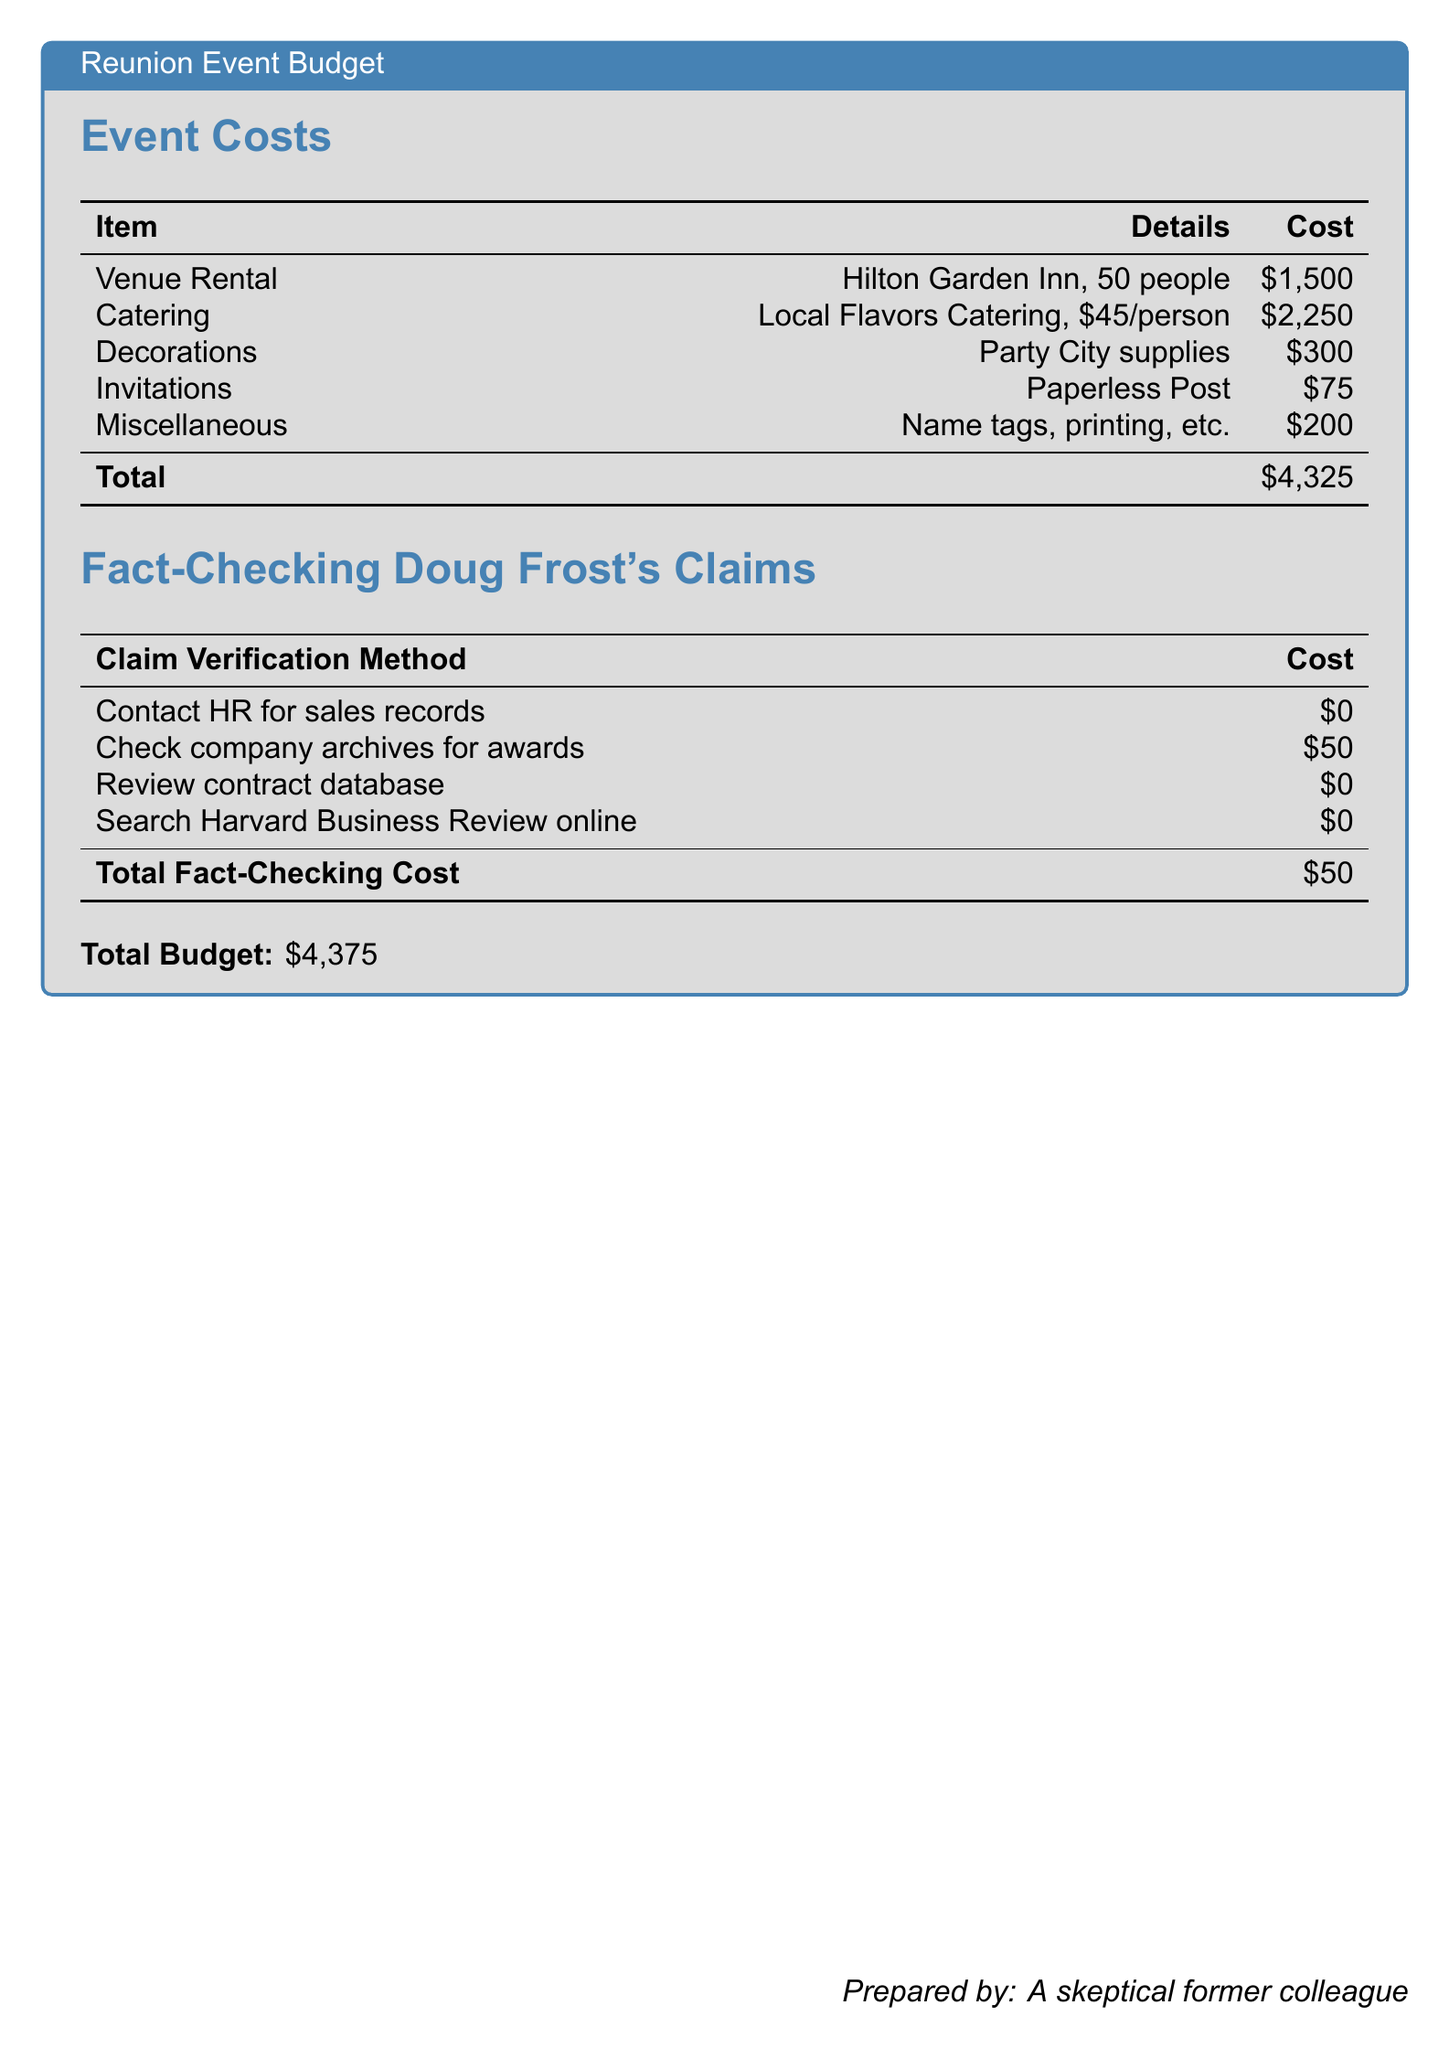What is the total cost of the reunion event? The total cost is listed in the budget section, which sums up all individual costs, amounting to $4,325.
Answer: $4,325 How much is allocated for catering per person? The catering cost is specified as $45 per person in the details.
Answer: $45 What is the total fact-checking cost? The total fact-checking cost is provided in the section detailing verification methods, which is $50.
Answer: $50 How many people is the venue rental for? The venue rental information indicates it is for 50 people.
Answer: 50 people What is the cost of decorations? The decorations cost is detailed in the budget as $300.
Answer: $300 What is the total budget for the reunion event including fact-checking? The total budget adds both the reunion event and fact-checking costs together, which is $4,325 + $50 = $4,375.
Answer: $4,375 How much does checking company archives for awards cost? The document states that checking company archives for awards incurs a cost of $50.
Answer: $50 What type of document is this? The document format is identified as an event budget for a reunion.
Answer: Event budget 